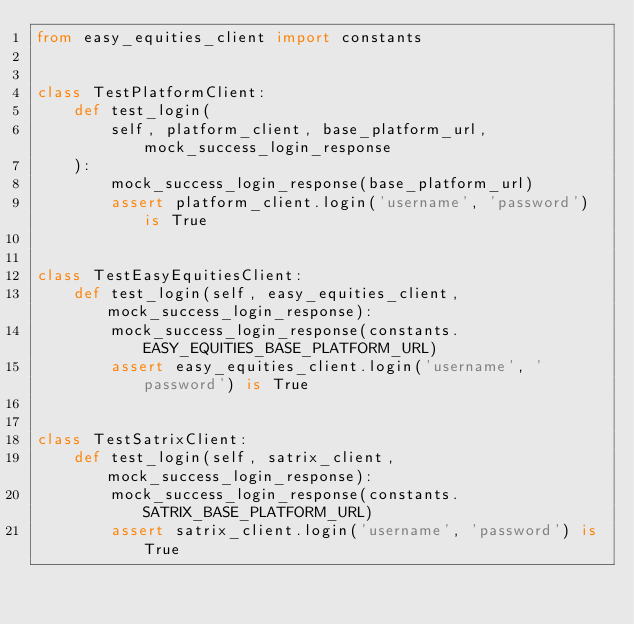Convert code to text. <code><loc_0><loc_0><loc_500><loc_500><_Python_>from easy_equities_client import constants


class TestPlatformClient:
    def test_login(
        self, platform_client, base_platform_url, mock_success_login_response
    ):
        mock_success_login_response(base_platform_url)
        assert platform_client.login('username', 'password') is True


class TestEasyEquitiesClient:
    def test_login(self, easy_equities_client, mock_success_login_response):
        mock_success_login_response(constants.EASY_EQUITIES_BASE_PLATFORM_URL)
        assert easy_equities_client.login('username', 'password') is True


class TestSatrixClient:
    def test_login(self, satrix_client, mock_success_login_response):
        mock_success_login_response(constants.SATRIX_BASE_PLATFORM_URL)
        assert satrix_client.login('username', 'password') is True
</code> 